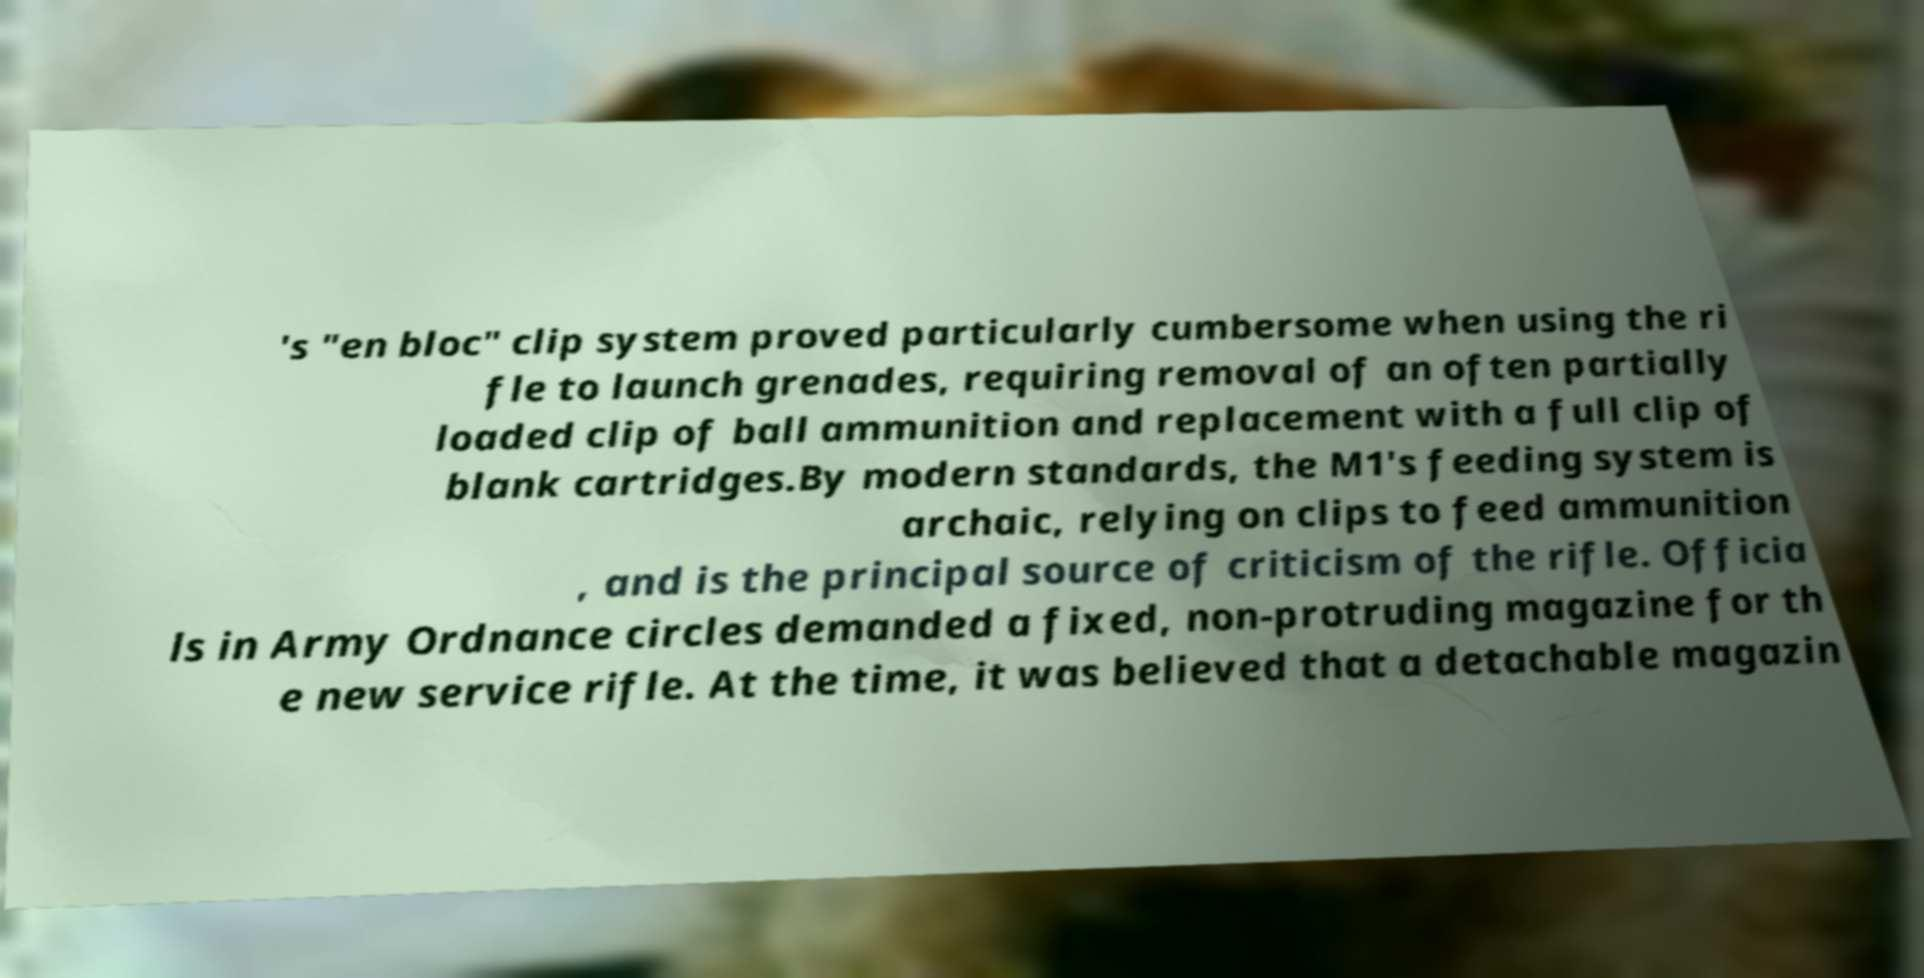Could you assist in decoding the text presented in this image and type it out clearly? 's "en bloc" clip system proved particularly cumbersome when using the ri fle to launch grenades, requiring removal of an often partially loaded clip of ball ammunition and replacement with a full clip of blank cartridges.By modern standards, the M1's feeding system is archaic, relying on clips to feed ammunition , and is the principal source of criticism of the rifle. Officia ls in Army Ordnance circles demanded a fixed, non-protruding magazine for th e new service rifle. At the time, it was believed that a detachable magazin 